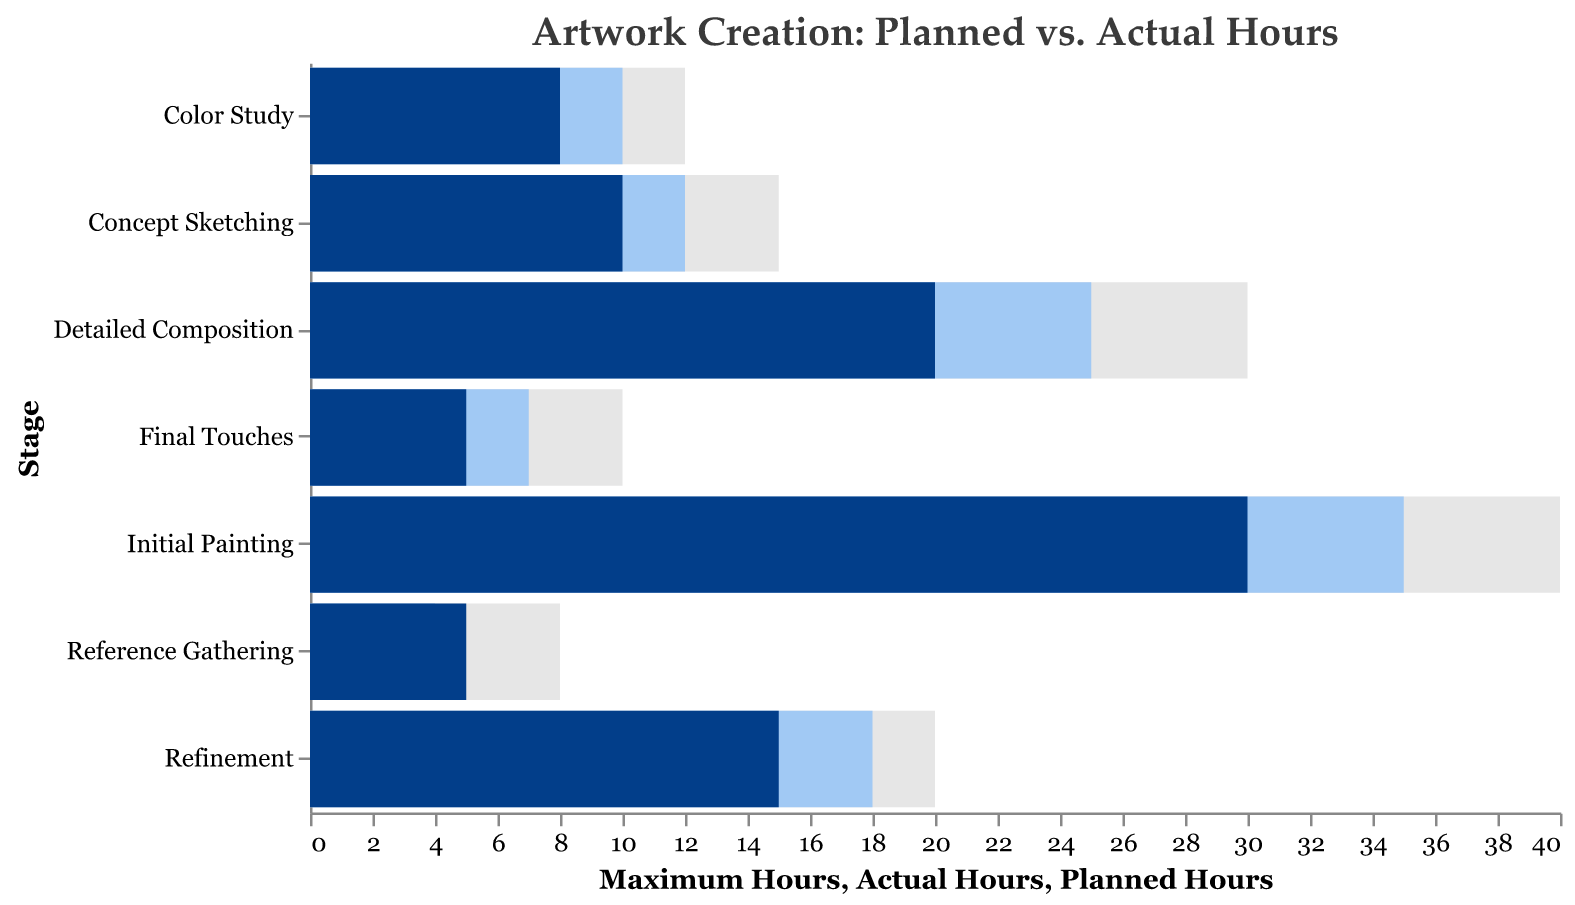What is the title of the figure? The title is usually at the top of the figure. In this case, it is given as "Artwork Creation: Planned vs. Actual Hours."
Answer: "Artwork Creation: Planned vs. Actual Hours" What color represents the "Planned Hours"? In the figure, the bars for "Planned Hours" are colored differently from "Actual Hours" and "Maximum Hours." According to the data, the "Planned Hours" bars are colored dark blue.
Answer: dark blue Which stage had the highest number of actual hours? By looking at the length of the bars representing "Actual Hours," you can identify that "Initial Painting" had the highest at 35 hours.
Answer: Initial Painting How many stages had actual hours exceeding the planned hours? By comparing the bar lengths for "Planned Hours" (dark blue) and "Actual Hours" (light blue) across all stages: "Concept Sketching," "Detailed Composition," "Color Study," "Initial Painting," "Refinement," and "Final Touches" exceed the planned hours.
Answer: 6 For which stage did the actual time spent fall under the planned time? Look for stages where the bar for "Actual Hours" (light blue) is shorter than that for "Planned Hours" (dark blue). This occurs in "Reference Gathering."
Answer: Reference Gathering What was the difference between actual and planned hours for "Detailed Composition"? The actual hours are 25, and planned hours are 20. The difference is calculated as 25 - 20.
Answer: 5 Which stages had actual hours within the maximum hours allocated? Compare the "Actual Hours" (light blue) with the "Maximum Hours" (gray). All stages had actual hours within their respective allocated maximum hours.
Answer: All stages What is the total planned hours for all stages combined? Sum the "Planned Hours" across all stages: 10 + 5 + 20 + 8 + 30 + 15 + 5 = 93.
Answer: 93 Which stage was closest to the planned hours without exceeding them? Compare the "Actual Hours" to the "Planned Hours" and find the smallest positive difference. "Reference Gathering" had 4 actual and 5 planned hours, so it was closest without exceeding.
Answer: Reference Gathering 